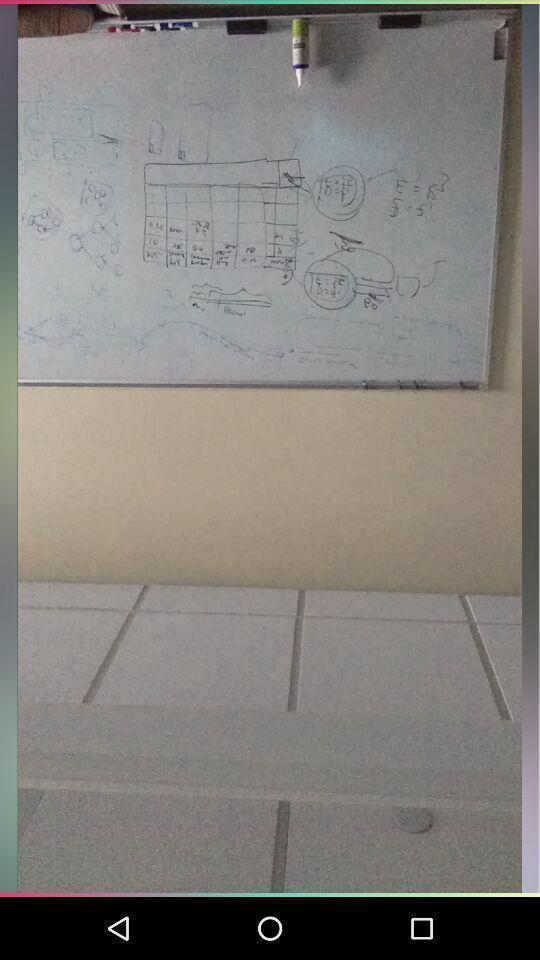Provide a textual representation of this image. Screen showing an image from gallery. 